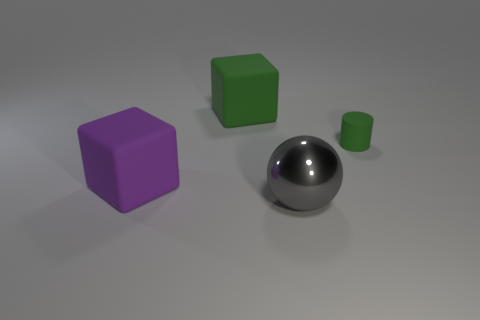There is a big cube that is the same color as the tiny rubber object; what is its material?
Provide a succinct answer. Rubber. What is the color of the large metal object?
Keep it short and to the point. Gray. There is a large block in front of the tiny rubber cylinder; are there any tiny green rubber cylinders that are on the right side of it?
Provide a succinct answer. Yes. What is the green block made of?
Offer a very short reply. Rubber. Are the cube that is behind the tiny rubber cylinder and the large sphere that is in front of the small green rubber cylinder made of the same material?
Offer a terse response. No. Is there anything else of the same color as the large metal ball?
Offer a very short reply. No. There is another rubber thing that is the same shape as the big purple thing; what is its color?
Ensure brevity in your answer.  Green. There is a thing that is both in front of the rubber cylinder and behind the shiny ball; what is its size?
Offer a terse response. Large. There is a green object on the left side of the large gray metal object; does it have the same shape as the rubber thing that is in front of the small green cylinder?
Offer a very short reply. Yes. What shape is the large matte thing that is the same color as the tiny thing?
Keep it short and to the point. Cube. 